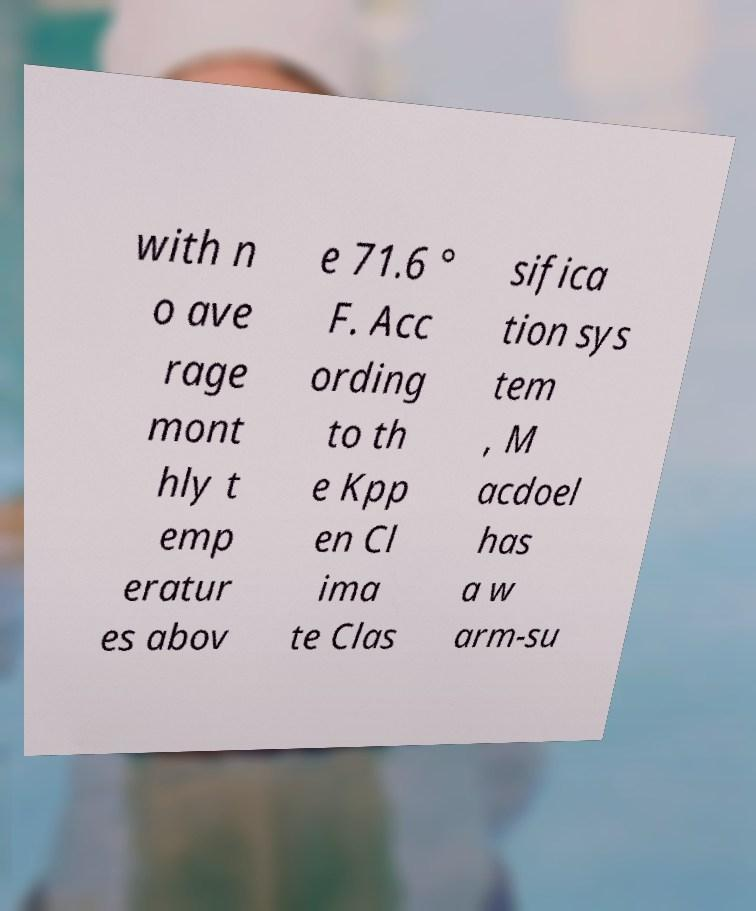Please identify and transcribe the text found in this image. with n o ave rage mont hly t emp eratur es abov e 71.6 ° F. Acc ording to th e Kpp en Cl ima te Clas sifica tion sys tem , M acdoel has a w arm-su 